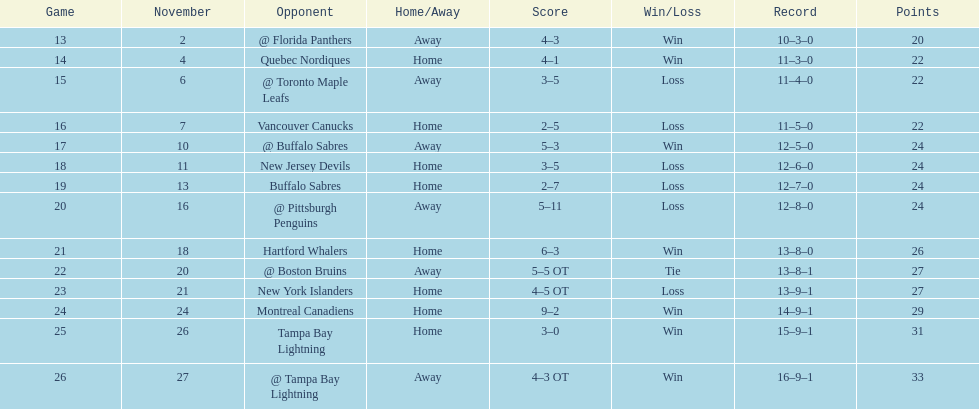Did the tampa bay lightning have the least amount of wins? Yes. 